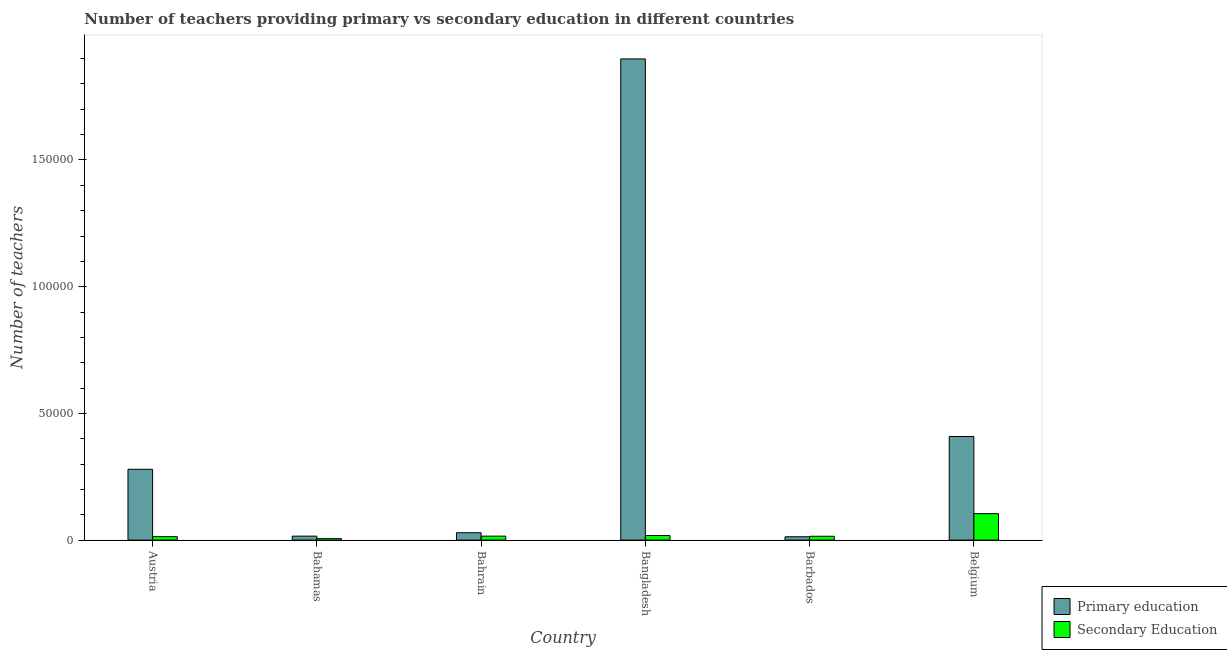How many different coloured bars are there?
Your answer should be very brief. 2. How many groups of bars are there?
Your answer should be compact. 6. How many bars are there on the 4th tick from the right?
Ensure brevity in your answer.  2. What is the label of the 2nd group of bars from the left?
Your answer should be very brief. Bahamas. In how many cases, is the number of bars for a given country not equal to the number of legend labels?
Offer a terse response. 0. What is the number of primary teachers in Bangladesh?
Keep it short and to the point. 1.90e+05. Across all countries, what is the maximum number of secondary teachers?
Provide a short and direct response. 1.04e+04. Across all countries, what is the minimum number of secondary teachers?
Offer a terse response. 581. In which country was the number of secondary teachers maximum?
Your response must be concise. Belgium. In which country was the number of secondary teachers minimum?
Your response must be concise. Bahamas. What is the total number of primary teachers in the graph?
Your answer should be very brief. 2.65e+05. What is the difference between the number of secondary teachers in Bangladesh and that in Belgium?
Ensure brevity in your answer.  -8638. What is the average number of primary teachers per country?
Keep it short and to the point. 4.41e+04. What is the difference between the number of primary teachers and number of secondary teachers in Austria?
Provide a succinct answer. 2.66e+04. What is the ratio of the number of secondary teachers in Bahamas to that in Bangladesh?
Give a very brief answer. 0.32. Is the number of secondary teachers in Bahrain less than that in Bangladesh?
Keep it short and to the point. Yes. What is the difference between the highest and the second highest number of primary teachers?
Give a very brief answer. 1.49e+05. What is the difference between the highest and the lowest number of secondary teachers?
Your answer should be very brief. 9858. In how many countries, is the number of secondary teachers greater than the average number of secondary teachers taken over all countries?
Give a very brief answer. 1. Is the sum of the number of primary teachers in Bahamas and Barbados greater than the maximum number of secondary teachers across all countries?
Offer a terse response. No. What does the 2nd bar from the right in Belgium represents?
Provide a short and direct response. Primary education. How many countries are there in the graph?
Ensure brevity in your answer.  6. What is the difference between two consecutive major ticks on the Y-axis?
Provide a short and direct response. 5.00e+04. Does the graph contain any zero values?
Offer a terse response. No. Does the graph contain grids?
Keep it short and to the point. No. How are the legend labels stacked?
Offer a terse response. Vertical. What is the title of the graph?
Ensure brevity in your answer.  Number of teachers providing primary vs secondary education in different countries. What is the label or title of the X-axis?
Your response must be concise. Country. What is the label or title of the Y-axis?
Offer a terse response. Number of teachers. What is the Number of teachers in Primary education in Austria?
Offer a terse response. 2.79e+04. What is the Number of teachers in Secondary Education in Austria?
Your response must be concise. 1368. What is the Number of teachers of Primary education in Bahamas?
Keep it short and to the point. 1565. What is the Number of teachers in Secondary Education in Bahamas?
Offer a very short reply. 581. What is the Number of teachers in Primary education in Bahrain?
Your answer should be compact. 2910. What is the Number of teachers in Secondary Education in Bahrain?
Provide a succinct answer. 1565. What is the Number of teachers in Primary education in Bangladesh?
Your answer should be very brief. 1.90e+05. What is the Number of teachers in Secondary Education in Bangladesh?
Give a very brief answer. 1801. What is the Number of teachers in Primary education in Barbados?
Ensure brevity in your answer.  1317. What is the Number of teachers in Secondary Education in Barbados?
Your response must be concise. 1512. What is the Number of teachers of Primary education in Belgium?
Offer a terse response. 4.09e+04. What is the Number of teachers of Secondary Education in Belgium?
Keep it short and to the point. 1.04e+04. Across all countries, what is the maximum Number of teachers in Primary education?
Offer a terse response. 1.90e+05. Across all countries, what is the maximum Number of teachers in Secondary Education?
Ensure brevity in your answer.  1.04e+04. Across all countries, what is the minimum Number of teachers in Primary education?
Your response must be concise. 1317. Across all countries, what is the minimum Number of teachers of Secondary Education?
Offer a terse response. 581. What is the total Number of teachers in Primary education in the graph?
Give a very brief answer. 2.65e+05. What is the total Number of teachers in Secondary Education in the graph?
Keep it short and to the point. 1.73e+04. What is the difference between the Number of teachers in Primary education in Austria and that in Bahamas?
Keep it short and to the point. 2.64e+04. What is the difference between the Number of teachers in Secondary Education in Austria and that in Bahamas?
Ensure brevity in your answer.  787. What is the difference between the Number of teachers in Primary education in Austria and that in Bahrain?
Your answer should be very brief. 2.50e+04. What is the difference between the Number of teachers of Secondary Education in Austria and that in Bahrain?
Ensure brevity in your answer.  -197. What is the difference between the Number of teachers of Primary education in Austria and that in Bangladesh?
Offer a terse response. -1.62e+05. What is the difference between the Number of teachers of Secondary Education in Austria and that in Bangladesh?
Keep it short and to the point. -433. What is the difference between the Number of teachers in Primary education in Austria and that in Barbados?
Your answer should be very brief. 2.66e+04. What is the difference between the Number of teachers in Secondary Education in Austria and that in Barbados?
Ensure brevity in your answer.  -144. What is the difference between the Number of teachers of Primary education in Austria and that in Belgium?
Your answer should be very brief. -1.30e+04. What is the difference between the Number of teachers of Secondary Education in Austria and that in Belgium?
Your answer should be compact. -9071. What is the difference between the Number of teachers in Primary education in Bahamas and that in Bahrain?
Offer a very short reply. -1345. What is the difference between the Number of teachers of Secondary Education in Bahamas and that in Bahrain?
Keep it short and to the point. -984. What is the difference between the Number of teachers in Primary education in Bahamas and that in Bangladesh?
Keep it short and to the point. -1.88e+05. What is the difference between the Number of teachers in Secondary Education in Bahamas and that in Bangladesh?
Your response must be concise. -1220. What is the difference between the Number of teachers in Primary education in Bahamas and that in Barbados?
Ensure brevity in your answer.  248. What is the difference between the Number of teachers in Secondary Education in Bahamas and that in Barbados?
Your response must be concise. -931. What is the difference between the Number of teachers of Primary education in Bahamas and that in Belgium?
Keep it short and to the point. -3.93e+04. What is the difference between the Number of teachers in Secondary Education in Bahamas and that in Belgium?
Give a very brief answer. -9858. What is the difference between the Number of teachers in Primary education in Bahrain and that in Bangladesh?
Your response must be concise. -1.87e+05. What is the difference between the Number of teachers in Secondary Education in Bahrain and that in Bangladesh?
Your response must be concise. -236. What is the difference between the Number of teachers in Primary education in Bahrain and that in Barbados?
Offer a terse response. 1593. What is the difference between the Number of teachers of Secondary Education in Bahrain and that in Barbados?
Make the answer very short. 53. What is the difference between the Number of teachers of Primary education in Bahrain and that in Belgium?
Your answer should be very brief. -3.80e+04. What is the difference between the Number of teachers of Secondary Education in Bahrain and that in Belgium?
Give a very brief answer. -8874. What is the difference between the Number of teachers in Primary education in Bangladesh and that in Barbados?
Your response must be concise. 1.89e+05. What is the difference between the Number of teachers in Secondary Education in Bangladesh and that in Barbados?
Your response must be concise. 289. What is the difference between the Number of teachers of Primary education in Bangladesh and that in Belgium?
Provide a short and direct response. 1.49e+05. What is the difference between the Number of teachers in Secondary Education in Bangladesh and that in Belgium?
Keep it short and to the point. -8638. What is the difference between the Number of teachers of Primary education in Barbados and that in Belgium?
Keep it short and to the point. -3.96e+04. What is the difference between the Number of teachers of Secondary Education in Barbados and that in Belgium?
Make the answer very short. -8927. What is the difference between the Number of teachers of Primary education in Austria and the Number of teachers of Secondary Education in Bahamas?
Keep it short and to the point. 2.74e+04. What is the difference between the Number of teachers of Primary education in Austria and the Number of teachers of Secondary Education in Bahrain?
Ensure brevity in your answer.  2.64e+04. What is the difference between the Number of teachers of Primary education in Austria and the Number of teachers of Secondary Education in Bangladesh?
Provide a succinct answer. 2.61e+04. What is the difference between the Number of teachers of Primary education in Austria and the Number of teachers of Secondary Education in Barbados?
Offer a terse response. 2.64e+04. What is the difference between the Number of teachers of Primary education in Austria and the Number of teachers of Secondary Education in Belgium?
Provide a short and direct response. 1.75e+04. What is the difference between the Number of teachers in Primary education in Bahamas and the Number of teachers in Secondary Education in Bangladesh?
Provide a short and direct response. -236. What is the difference between the Number of teachers in Primary education in Bahamas and the Number of teachers in Secondary Education in Barbados?
Provide a succinct answer. 53. What is the difference between the Number of teachers in Primary education in Bahamas and the Number of teachers in Secondary Education in Belgium?
Make the answer very short. -8874. What is the difference between the Number of teachers of Primary education in Bahrain and the Number of teachers of Secondary Education in Bangladesh?
Your answer should be compact. 1109. What is the difference between the Number of teachers in Primary education in Bahrain and the Number of teachers in Secondary Education in Barbados?
Make the answer very short. 1398. What is the difference between the Number of teachers of Primary education in Bahrain and the Number of teachers of Secondary Education in Belgium?
Make the answer very short. -7529. What is the difference between the Number of teachers of Primary education in Bangladesh and the Number of teachers of Secondary Education in Barbados?
Keep it short and to the point. 1.88e+05. What is the difference between the Number of teachers of Primary education in Bangladesh and the Number of teachers of Secondary Education in Belgium?
Make the answer very short. 1.79e+05. What is the difference between the Number of teachers of Primary education in Barbados and the Number of teachers of Secondary Education in Belgium?
Your response must be concise. -9122. What is the average Number of teachers in Primary education per country?
Ensure brevity in your answer.  4.41e+04. What is the average Number of teachers of Secondary Education per country?
Give a very brief answer. 2877.67. What is the difference between the Number of teachers in Primary education and Number of teachers in Secondary Education in Austria?
Offer a very short reply. 2.66e+04. What is the difference between the Number of teachers in Primary education and Number of teachers in Secondary Education in Bahamas?
Offer a very short reply. 984. What is the difference between the Number of teachers in Primary education and Number of teachers in Secondary Education in Bahrain?
Ensure brevity in your answer.  1345. What is the difference between the Number of teachers of Primary education and Number of teachers of Secondary Education in Bangladesh?
Make the answer very short. 1.88e+05. What is the difference between the Number of teachers in Primary education and Number of teachers in Secondary Education in Barbados?
Make the answer very short. -195. What is the difference between the Number of teachers in Primary education and Number of teachers in Secondary Education in Belgium?
Provide a short and direct response. 3.05e+04. What is the ratio of the Number of teachers of Primary education in Austria to that in Bahamas?
Your answer should be very brief. 17.85. What is the ratio of the Number of teachers of Secondary Education in Austria to that in Bahamas?
Your answer should be very brief. 2.35. What is the ratio of the Number of teachers in Primary education in Austria to that in Bahrain?
Provide a succinct answer. 9.6. What is the ratio of the Number of teachers of Secondary Education in Austria to that in Bahrain?
Provide a succinct answer. 0.87. What is the ratio of the Number of teachers of Primary education in Austria to that in Bangladesh?
Provide a succinct answer. 0.15. What is the ratio of the Number of teachers of Secondary Education in Austria to that in Bangladesh?
Offer a very short reply. 0.76. What is the ratio of the Number of teachers of Primary education in Austria to that in Barbados?
Provide a succinct answer. 21.22. What is the ratio of the Number of teachers of Secondary Education in Austria to that in Barbados?
Your response must be concise. 0.9. What is the ratio of the Number of teachers of Primary education in Austria to that in Belgium?
Keep it short and to the point. 0.68. What is the ratio of the Number of teachers in Secondary Education in Austria to that in Belgium?
Your answer should be very brief. 0.13. What is the ratio of the Number of teachers of Primary education in Bahamas to that in Bahrain?
Your answer should be compact. 0.54. What is the ratio of the Number of teachers of Secondary Education in Bahamas to that in Bahrain?
Your answer should be very brief. 0.37. What is the ratio of the Number of teachers in Primary education in Bahamas to that in Bangladesh?
Ensure brevity in your answer.  0.01. What is the ratio of the Number of teachers of Secondary Education in Bahamas to that in Bangladesh?
Offer a very short reply. 0.32. What is the ratio of the Number of teachers of Primary education in Bahamas to that in Barbados?
Make the answer very short. 1.19. What is the ratio of the Number of teachers in Secondary Education in Bahamas to that in Barbados?
Your answer should be very brief. 0.38. What is the ratio of the Number of teachers of Primary education in Bahamas to that in Belgium?
Make the answer very short. 0.04. What is the ratio of the Number of teachers in Secondary Education in Bahamas to that in Belgium?
Your answer should be very brief. 0.06. What is the ratio of the Number of teachers of Primary education in Bahrain to that in Bangladesh?
Your answer should be very brief. 0.02. What is the ratio of the Number of teachers of Secondary Education in Bahrain to that in Bangladesh?
Offer a terse response. 0.87. What is the ratio of the Number of teachers in Primary education in Bahrain to that in Barbados?
Offer a very short reply. 2.21. What is the ratio of the Number of teachers in Secondary Education in Bahrain to that in Barbados?
Give a very brief answer. 1.04. What is the ratio of the Number of teachers of Primary education in Bahrain to that in Belgium?
Give a very brief answer. 0.07. What is the ratio of the Number of teachers of Secondary Education in Bahrain to that in Belgium?
Keep it short and to the point. 0.15. What is the ratio of the Number of teachers in Primary education in Bangladesh to that in Barbados?
Make the answer very short. 144.18. What is the ratio of the Number of teachers in Secondary Education in Bangladesh to that in Barbados?
Offer a terse response. 1.19. What is the ratio of the Number of teachers of Primary education in Bangladesh to that in Belgium?
Make the answer very short. 4.64. What is the ratio of the Number of teachers of Secondary Education in Bangladesh to that in Belgium?
Offer a terse response. 0.17. What is the ratio of the Number of teachers of Primary education in Barbados to that in Belgium?
Give a very brief answer. 0.03. What is the ratio of the Number of teachers in Secondary Education in Barbados to that in Belgium?
Provide a short and direct response. 0.14. What is the difference between the highest and the second highest Number of teachers in Primary education?
Ensure brevity in your answer.  1.49e+05. What is the difference between the highest and the second highest Number of teachers in Secondary Education?
Your answer should be very brief. 8638. What is the difference between the highest and the lowest Number of teachers of Primary education?
Your response must be concise. 1.89e+05. What is the difference between the highest and the lowest Number of teachers of Secondary Education?
Make the answer very short. 9858. 